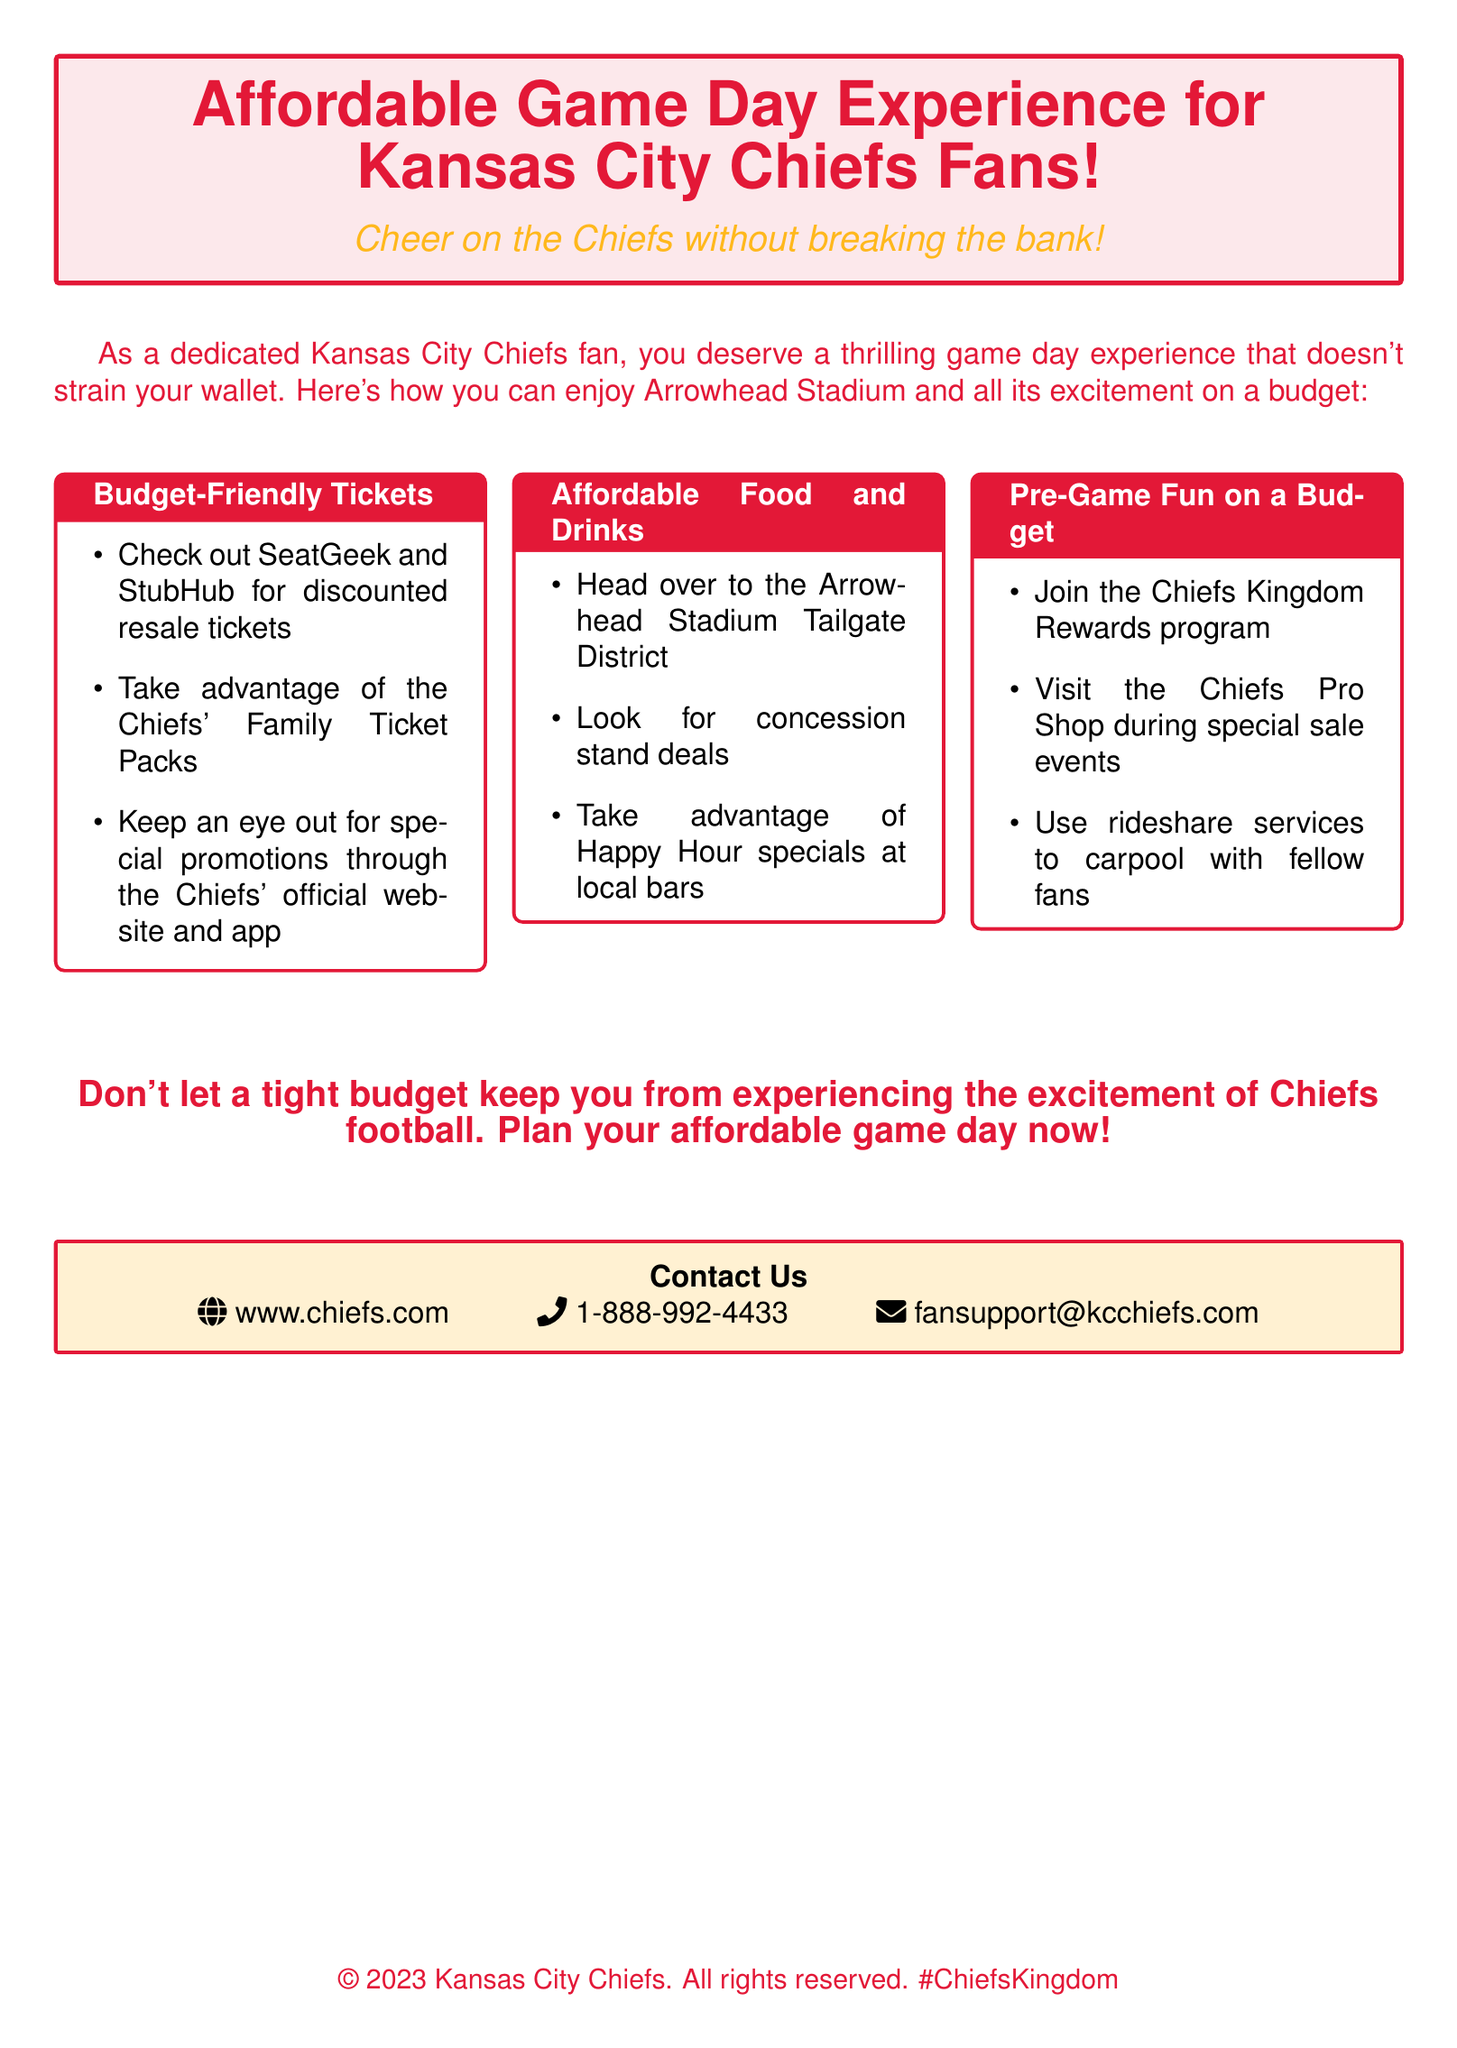What is highlighted as a budget-friendly option for attending games? The document mentions budget-friendly tickets, affordable food and drinks, and pre-game fun on a budget.
Answer: Tickets, food, drinks, pre-game fun Which service is recommended for discounted resale tickets? The document suggests checking out SeatGeek and StubHub for discounted resale tickets.
Answer: SeatGeek and StubHub What program can fans join for rewards? The document refers to the Chiefs Kingdom Rewards program for fans looking for incentives.
Answer: Chiefs Kingdom Rewards What is mentioned as a way to save on food at the stadium? The document advises looking for concession stand deals as a way to save on food.
Answer: Concession stand deals What is the contact email for fan support? The contact email for fan support is listed in the document as fansupport@kcchiefs.com.
Answer: fansupport@kcchiefs.com How can fans reduce transportation costs? The document notes using rideshare services to carpool with fellow fans as a recommendation.
Answer: Rideshare services What color is the Chiefs' brand in the document? The document uses the color 'chiefsred' for branding and highlights.
Answer: Chiefs red Which district is recommended for affordable food options? The Tailgate District at Arrowhead Stadium is suggested in the document for affordable food options.
Answer: Tailgate District What should fans watch for on the Chiefs' official website? Fans should keep an eye out for special promotions through the Chiefs' official website and app, as stated in the document.
Answer: Special promotions 